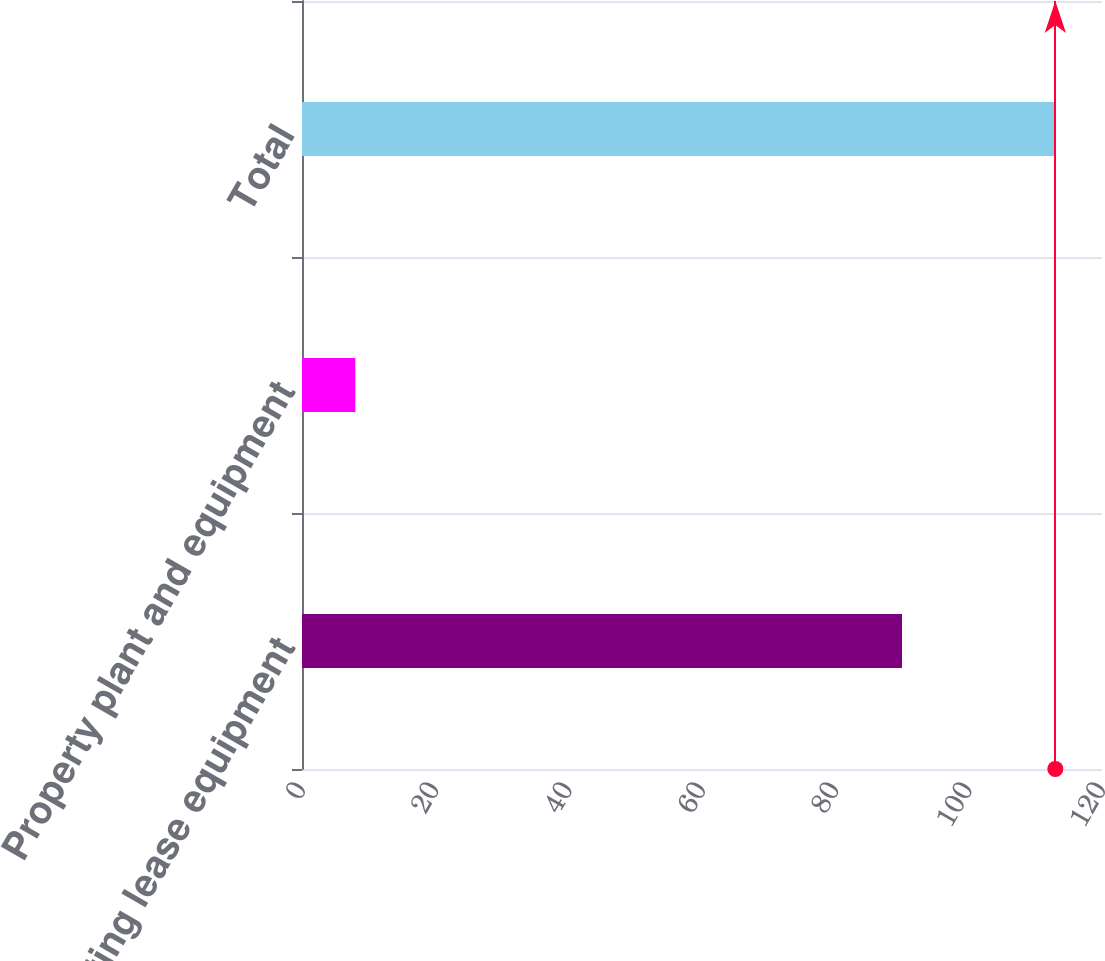<chart> <loc_0><loc_0><loc_500><loc_500><bar_chart><fcel>Operating lease equipment<fcel>Property plant and equipment<fcel>Total<nl><fcel>90<fcel>8<fcel>113<nl></chart> 